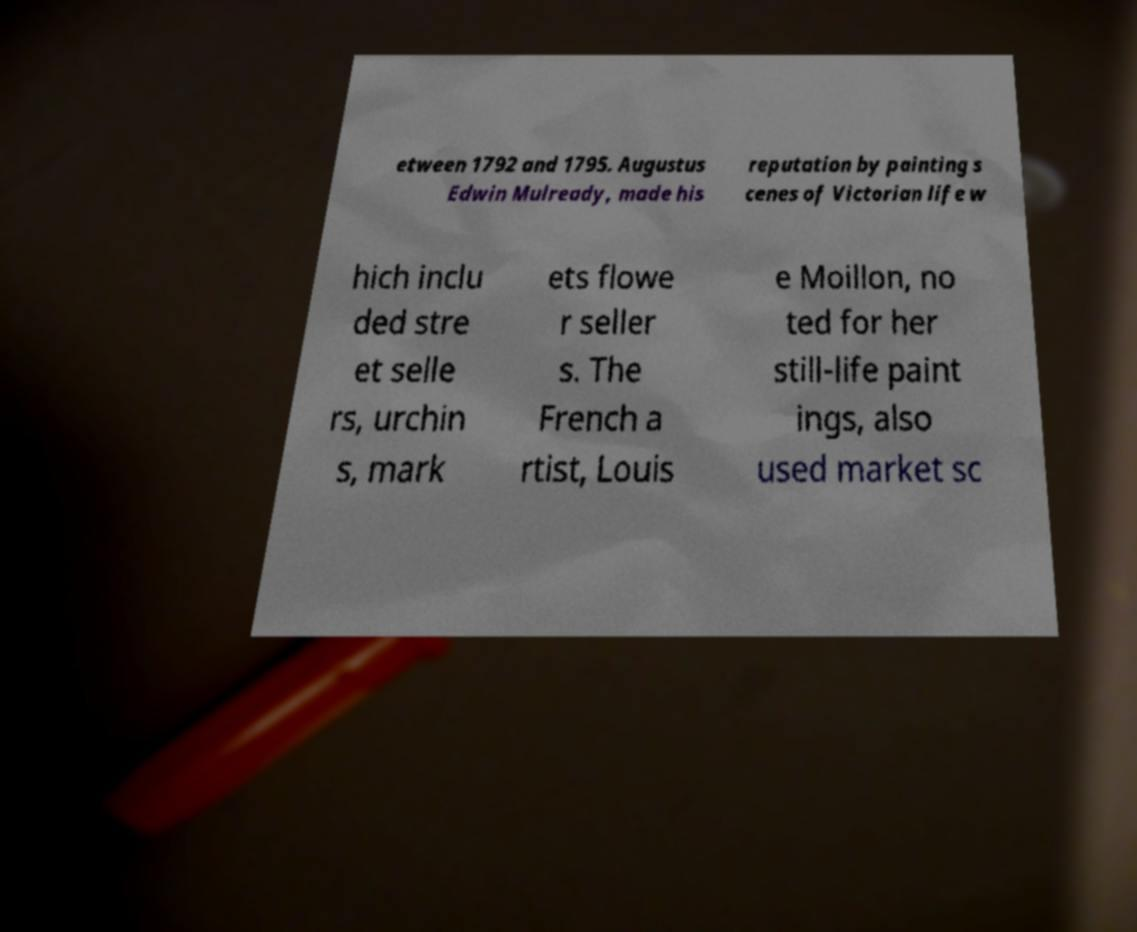I need the written content from this picture converted into text. Can you do that? etween 1792 and 1795. Augustus Edwin Mulready, made his reputation by painting s cenes of Victorian life w hich inclu ded stre et selle rs, urchin s, mark ets flowe r seller s. The French a rtist, Louis e Moillon, no ted for her still-life paint ings, also used market sc 